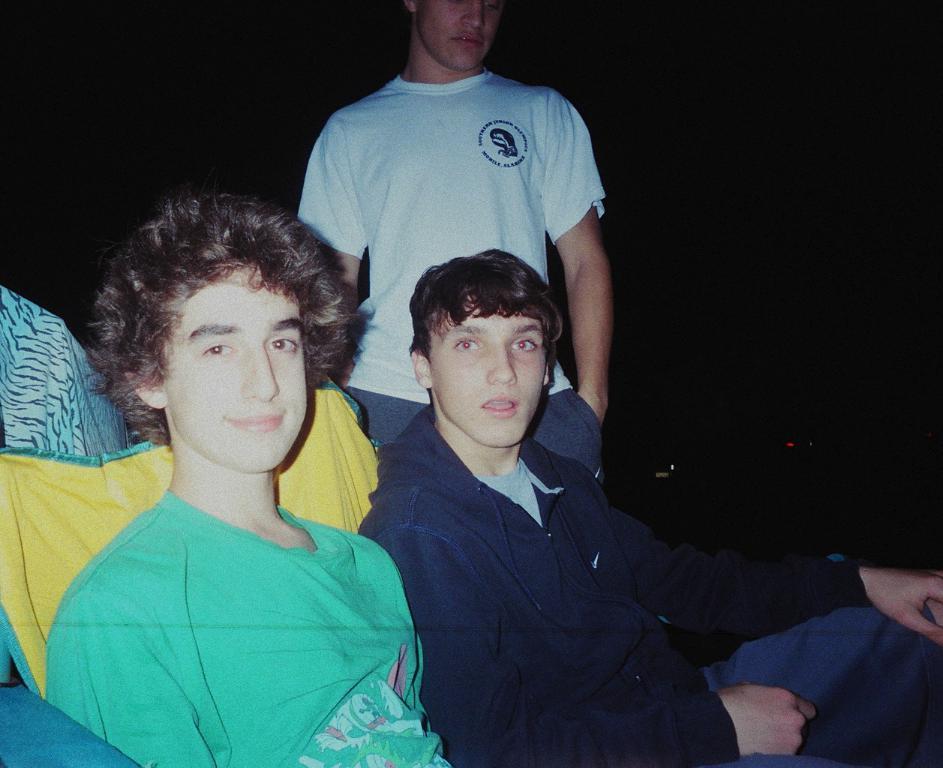How would you summarize this image in a sentence or two? In this image the background is dark. On the left side of the image a boy is sitting on the chair and there is another person. In the middle of the image a boy is sitting on the chair and another boy is standing. 